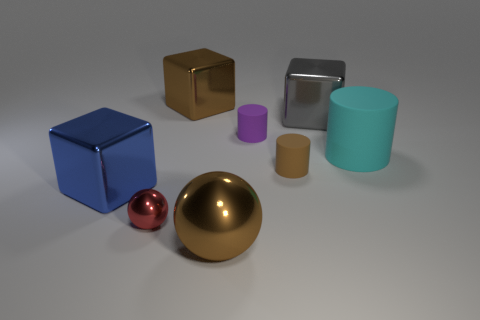Is there a brown shiny block of the same size as the red thing?
Provide a short and direct response. No. What number of shiny objects are large blue cubes or big gray things?
Make the answer very short. 2. The big object that is the same color as the large metallic ball is what shape?
Give a very brief answer. Cube. What number of tiny spheres are there?
Your response must be concise. 1. Do the object behind the gray metallic block and the big block that is in front of the large gray cube have the same material?
Provide a short and direct response. Yes. There is a red sphere that is made of the same material as the gray thing; what size is it?
Keep it short and to the point. Small. There is a small brown rubber object on the right side of the large ball; what is its shape?
Offer a terse response. Cylinder. Does the large cube to the left of the tiny sphere have the same color as the large rubber object that is behind the blue metal thing?
Your answer should be compact. No. There is a metallic block that is the same color as the big shiny ball; what is its size?
Provide a succinct answer. Large. Is there a big red matte block?
Give a very brief answer. No. 